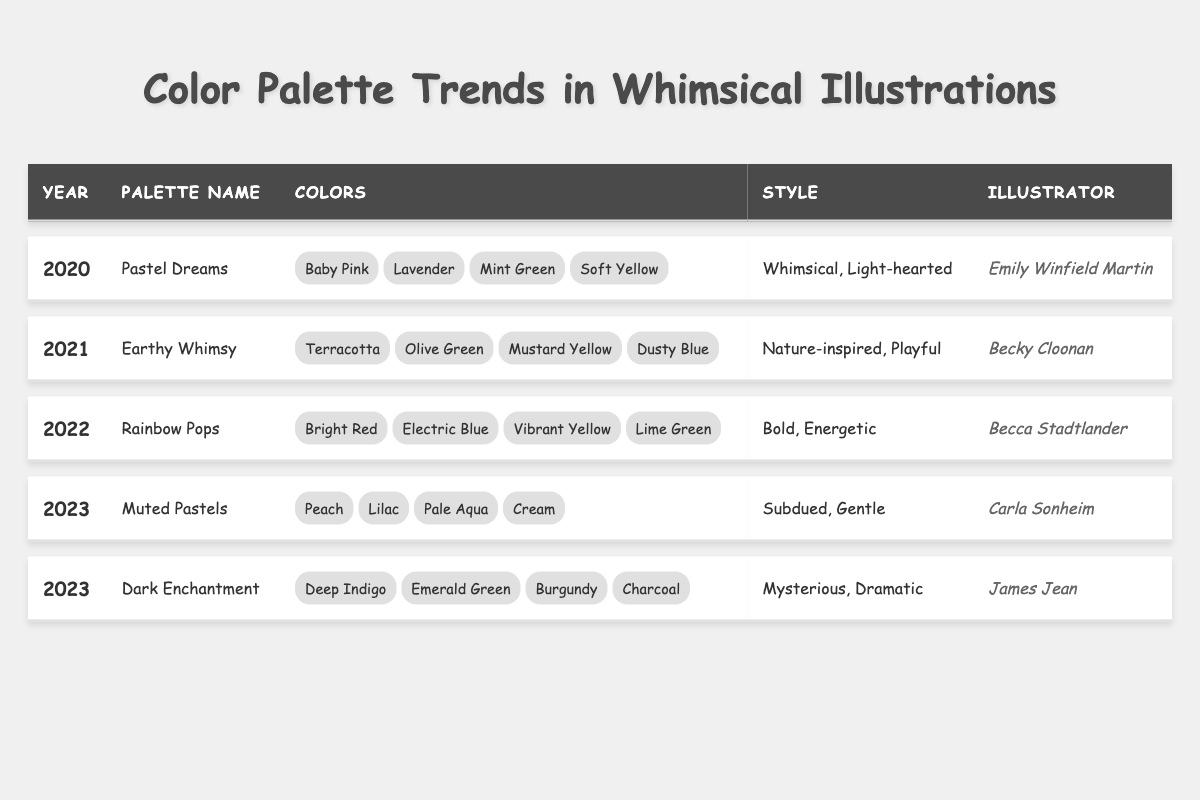What color is included in the "Pastel Dreams" palette? Referring to the table, the "Pastel Dreams" palette includes colors such as Baby Pink, Lavender, Mint Green, and Soft Yellow. Since the question asks for any one color in that palette, we can simply name one of them, for example, Baby Pink.
Answer: Baby Pink Which illustrator created the "Earthy Whimsy" palette? Looking directly at the table, the illustrator listed for the "Earthy Whimsy" palette is Becky Cloonan.
Answer: Becky Cloonan What is the style of the "Rainbow Pops" palette? The table indicates that the style for the "Rainbow Pops" palette is Bold, Energetic. This can be directly retrieved from the respective row in the table.
Answer: Bold, Energetic How many palettes were introduced in 2023? From the table, we observe that there are two palettes listed for the year 2023: "Muted Pastels" and "Dark Enchantment." Therefore, by counting these entries, we find there are two palettes.
Answer: 2 Which year features a palette with a name indicating softness? The table shows that the "Pastel Dreams" palette, characterized as Whimsical and Light-hearted, appears in 2020. The name itself suggests softness. Thus, we conclude that 2020 is the year in question.
Answer: 2020 Is "Dusty Blue" part of any color palette in 2021? By examining the table, we see that "Dusty Blue" is included in the "Earthy Whimsy" palette, which is created in 2021. Hence, the answer is yes, confirming the presence of Dusty Blue.
Answer: Yes Compare the number of colors in the "Muted Pastels" and "Dark Enchantment" palettes. Both palettes in question have four colors each listed in the table. By evaluating the rows for "Muted Pastels" and "Dark Enchantment," we find four color entries for each. Therefore, they both contain the same number of colors.
Answer: 4 What is the average number of years for the palettes listed in the table? The table contains entries from 2020 to 2023. There are a total of 5 palettes spanning 4 years. To find the average year, we sum 2020, 2021, 2022, and 2023, divide by the number of palettes. So (2020 + 2021 + 2022 + 2023) / 5 = 2021.2. Rounding to the nearest year indicates the average year is 2021.
Answer: 2021 Which palette’s colors include "Emerald Green" and which style does it represent? Referring to the table, "Emerald Green" is part of the "Dark Enchantment" palette, which has a style described as Mysterious, Dramatic. This is confirmed by matching the colors to the correct palette.
Answer: Dark Enchantment; Mysterious, Dramatic What is the total number of unique color names across all palettes? By listing all unique colors from each palette in the table, we aggregate: Baby Pink, Lavender, Mint Green, Soft Yellow, Terracotta, Olive Green, Mustard Yellow, Dusty Blue, Bright Red, Electric Blue, Vibrant Yellow, Lime Green, Peach, Lilac, Pale Aqua, Cream, Deep Indigo, Emerald Green, Burgundy, and Charcoal. This results in a total of 20 unique color names.
Answer: 20 